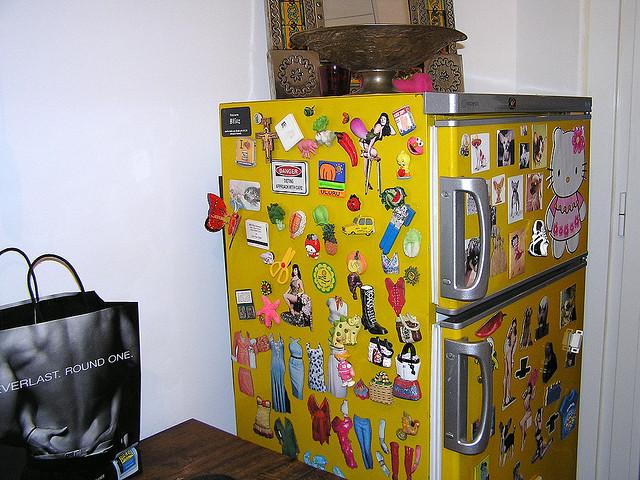How many doors are on the fridge?
Be succinct. 2. What does the text on the bag say?
Be succinct. Everlast round one. Was the fridge built for a left or right handed user?
Concise answer only. Left. 